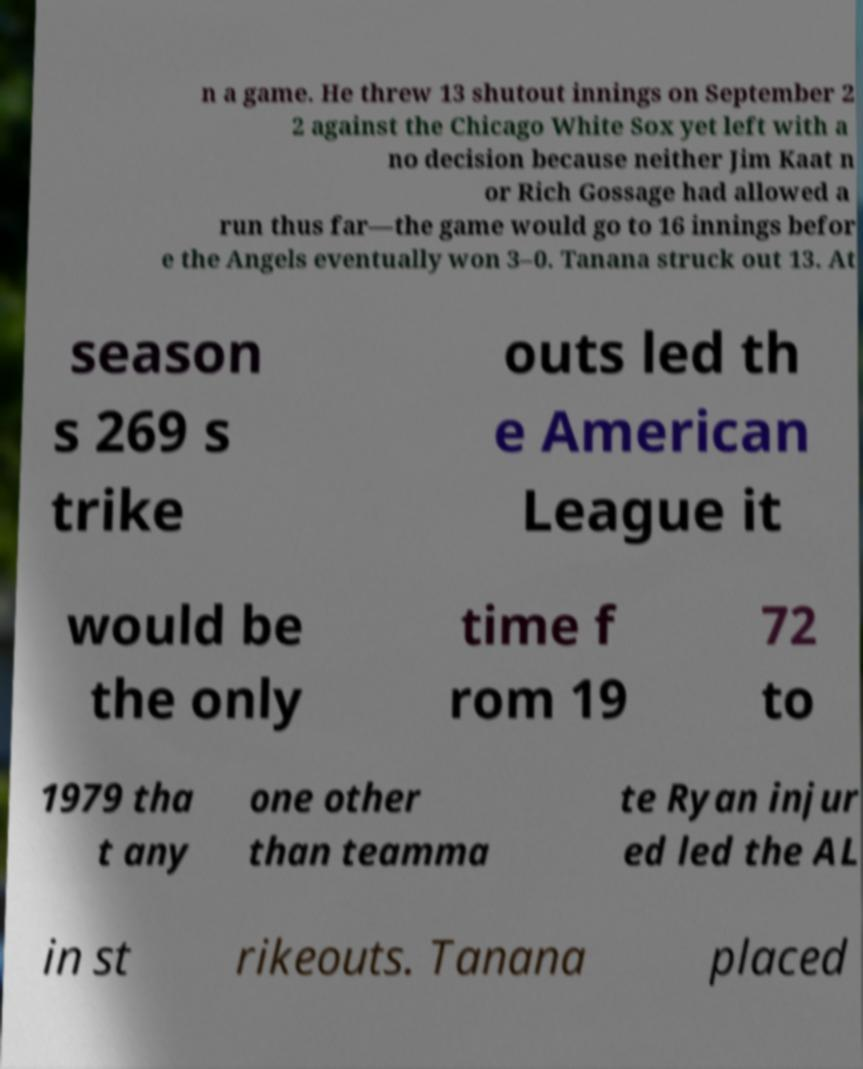For documentation purposes, I need the text within this image transcribed. Could you provide that? n a game. He threw 13 shutout innings on September 2 2 against the Chicago White Sox yet left with a no decision because neither Jim Kaat n or Rich Gossage had allowed a run thus far—the game would go to 16 innings befor e the Angels eventually won 3–0. Tanana struck out 13. At season s 269 s trike outs led th e American League it would be the only time f rom 19 72 to 1979 tha t any one other than teamma te Ryan injur ed led the AL in st rikeouts. Tanana placed 